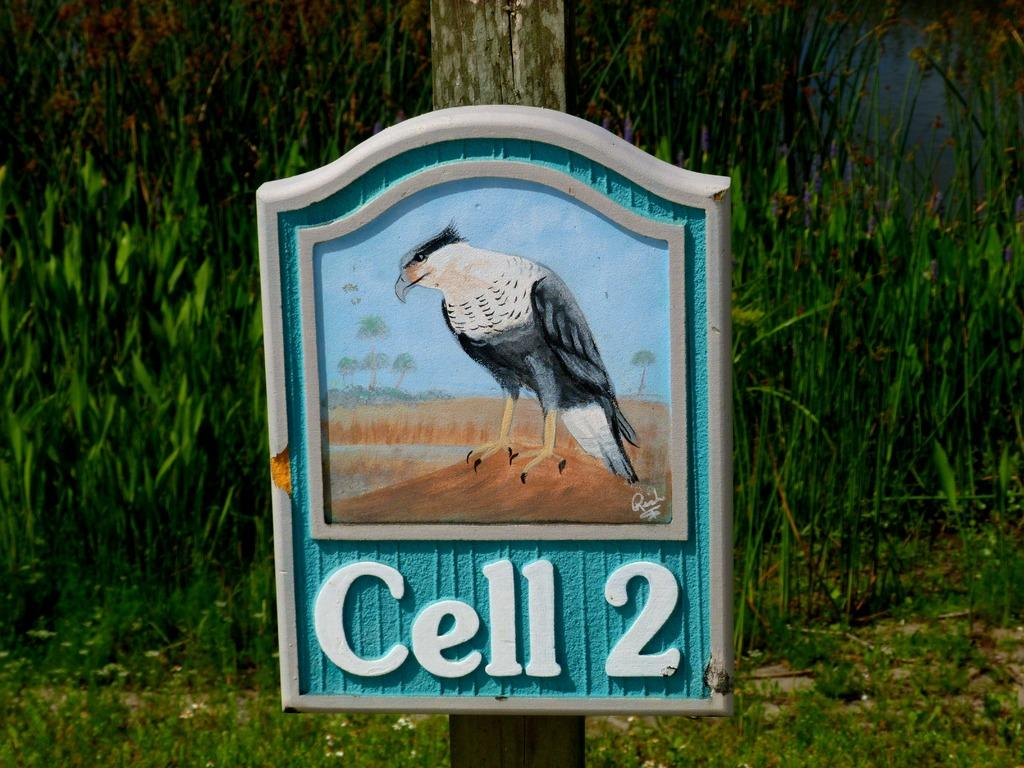What is the main object in the center of the image? There is a board attached to a pole in the center of the image. What can be seen in the background of the image? There are plants and water visible in the background of the image. What type of quartz can be seen on the board in the image? There is no quartz present on the board in the image. How many steps are visible in the image? There are no steps visible in the image. 